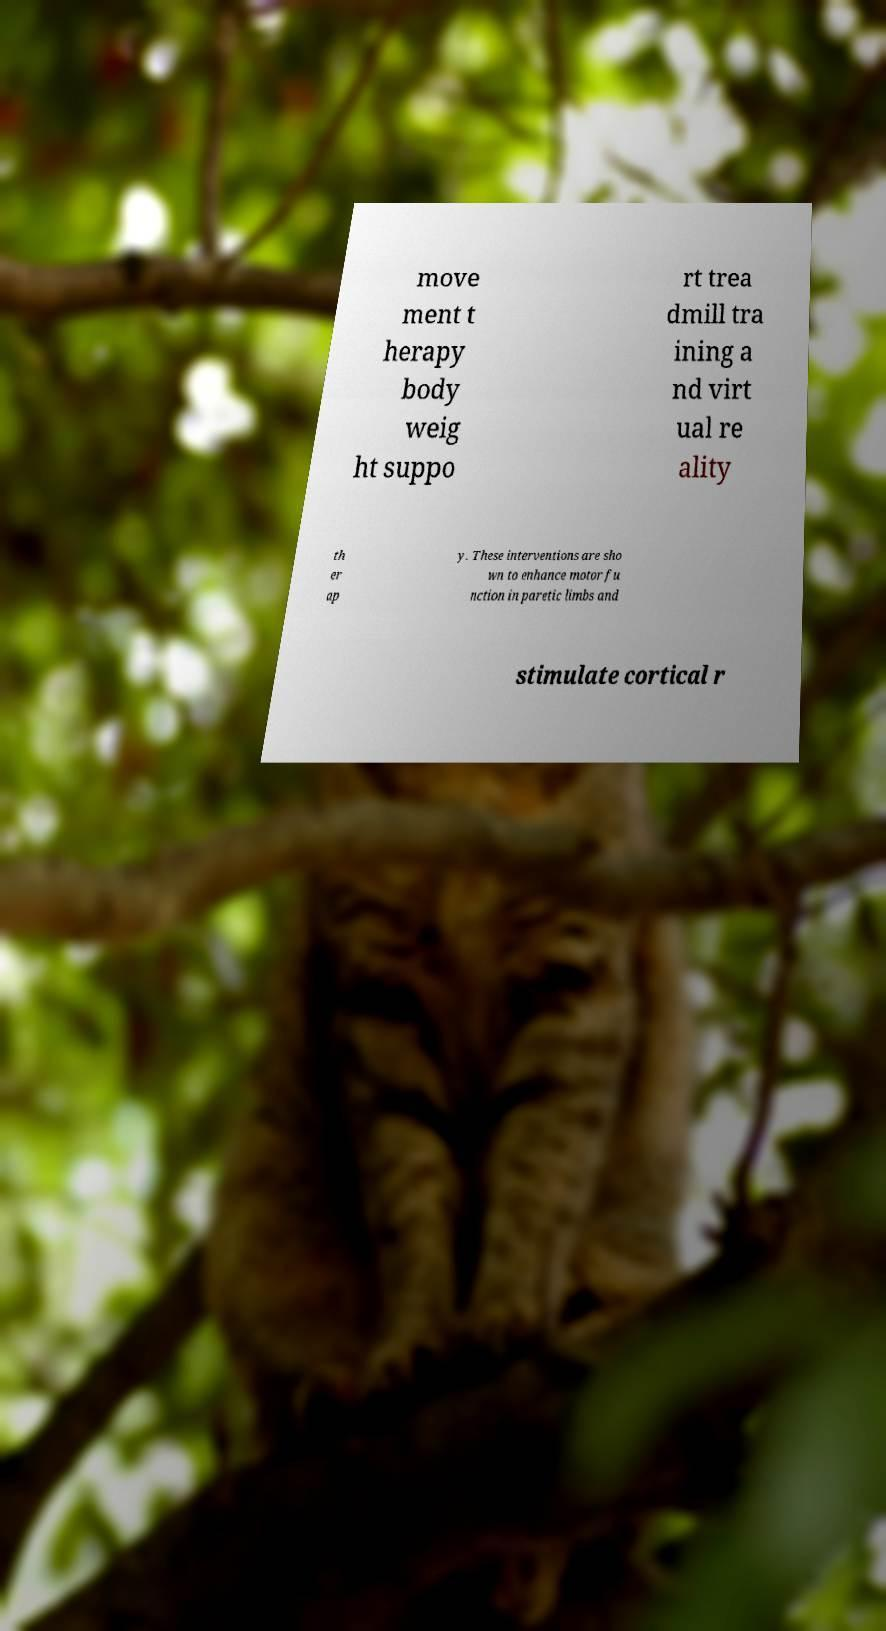For documentation purposes, I need the text within this image transcribed. Could you provide that? move ment t herapy body weig ht suppo rt trea dmill tra ining a nd virt ual re ality th er ap y. These interventions are sho wn to enhance motor fu nction in paretic limbs and stimulate cortical r 